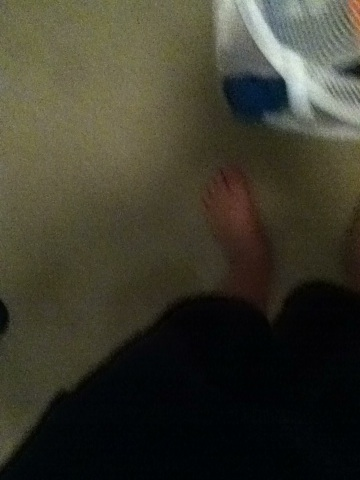If these feet could talk, what stories would they tell? If these feet could talk, they might tell tales of daily adventures, from the mornings spent shuffling through the house in search of socks to the lazy evenings spent unwinding after a long day. They could recount the places they've walked, the surfaces they've encountered, and the myriad of activities they've been part of, offering a unique perspective on the individual's life journeys. 